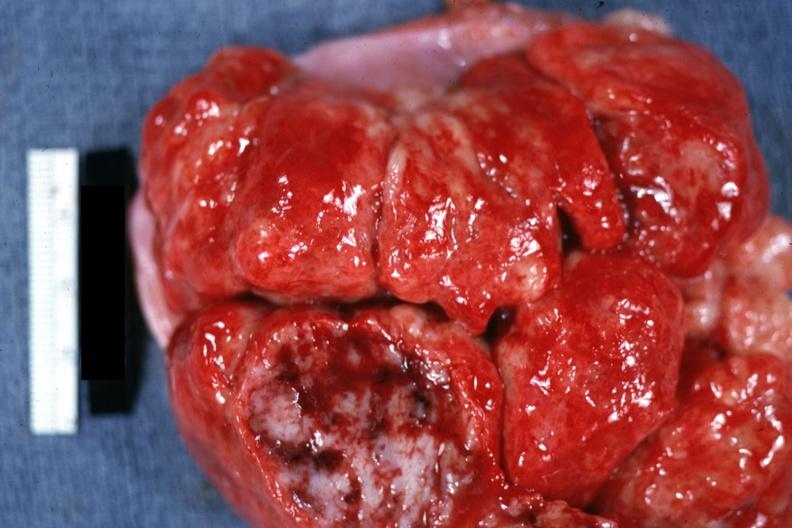what is present?
Answer the question using a single word or phrase. Acute lymphocytic leukemia 